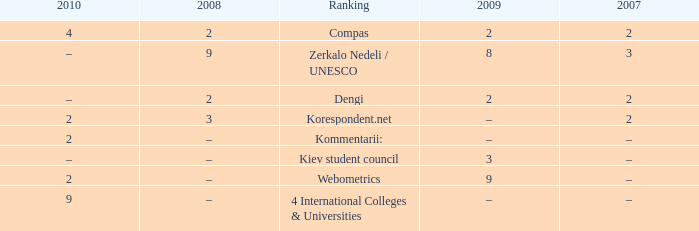What was the 2009 ranking for Webometrics? 9.0. 